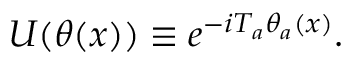Convert formula to latex. <formula><loc_0><loc_0><loc_500><loc_500>U ( \theta ( x ) ) \equiv e ^ { - i T _ { a } \theta _ { a } ( x ) } .</formula> 